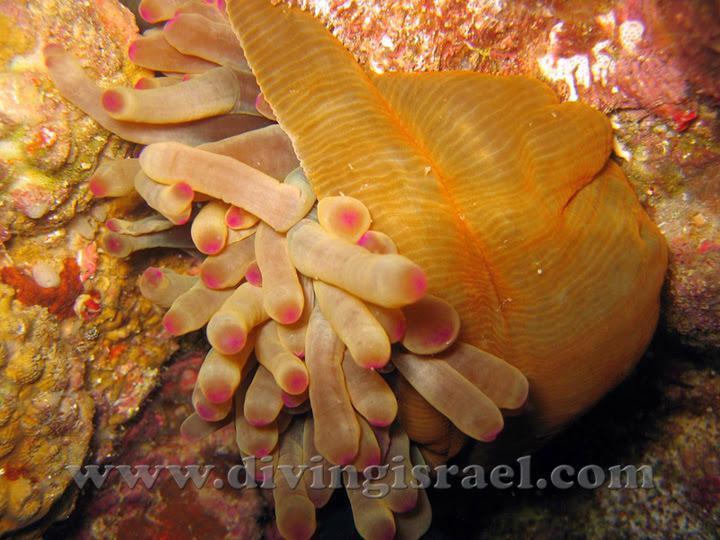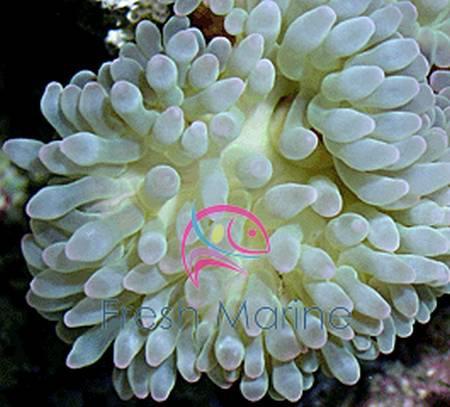The first image is the image on the left, the second image is the image on the right. Evaluate the accuracy of this statement regarding the images: "there are two anemones in each image pair". Is it true? Answer yes or no. No. The first image is the image on the left, the second image is the image on the right. Considering the images on both sides, is "There are only two anemones and at least one of them appears to be on a natural rock surface." valid? Answer yes or no. Yes. 